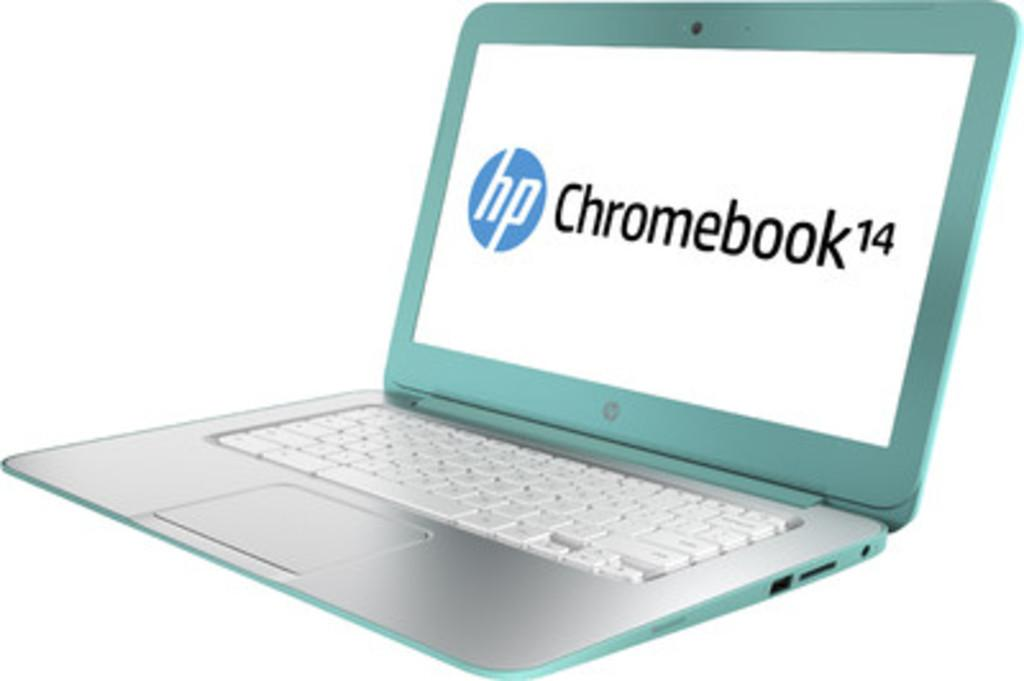<image>
Describe the image concisely. An open laptop with HP Chromebook written on the screen. 